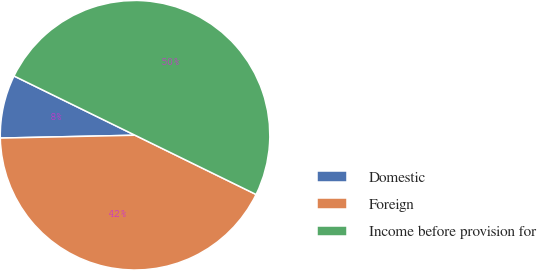Convert chart to OTSL. <chart><loc_0><loc_0><loc_500><loc_500><pie_chart><fcel>Domestic<fcel>Foreign<fcel>Income before provision for<nl><fcel>7.58%<fcel>42.42%<fcel>50.0%<nl></chart> 